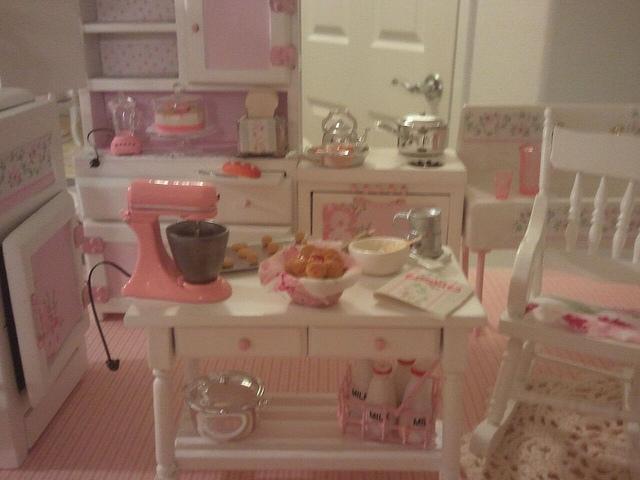Is this a working kitchen?
Quick response, please. No. How many toy pots are there?
Answer briefly. 2. What color is the mixer?
Give a very brief answer. Pink. Is this a play kitchen?
Answer briefly. Yes. 